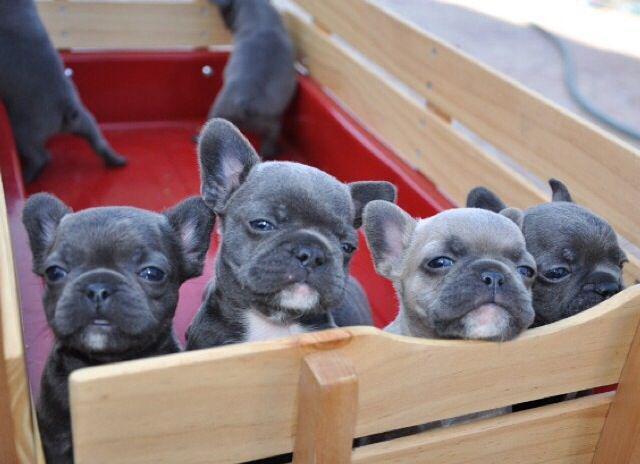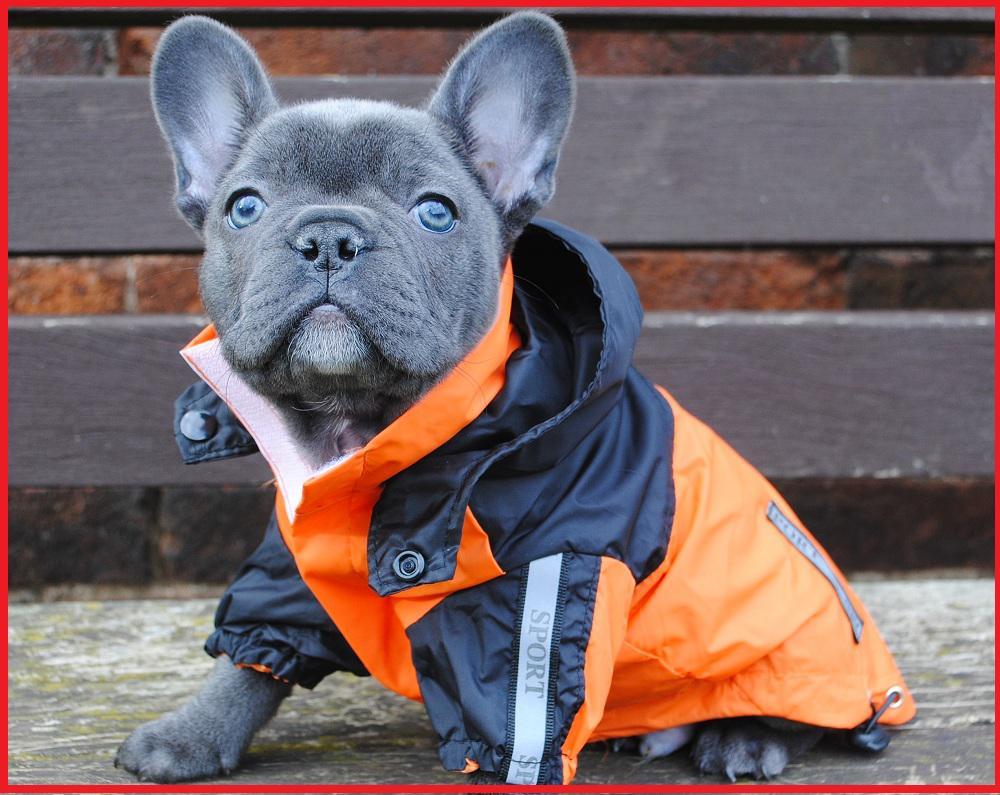The first image is the image on the left, the second image is the image on the right. For the images displayed, is the sentence "There is only one puppy in the picture on the left." factually correct? Answer yes or no. No. The first image is the image on the left, the second image is the image on the right. Analyze the images presented: Is the assertion "An image shows a row of at least three puppies of the same overall color." valid? Answer yes or no. Yes. 